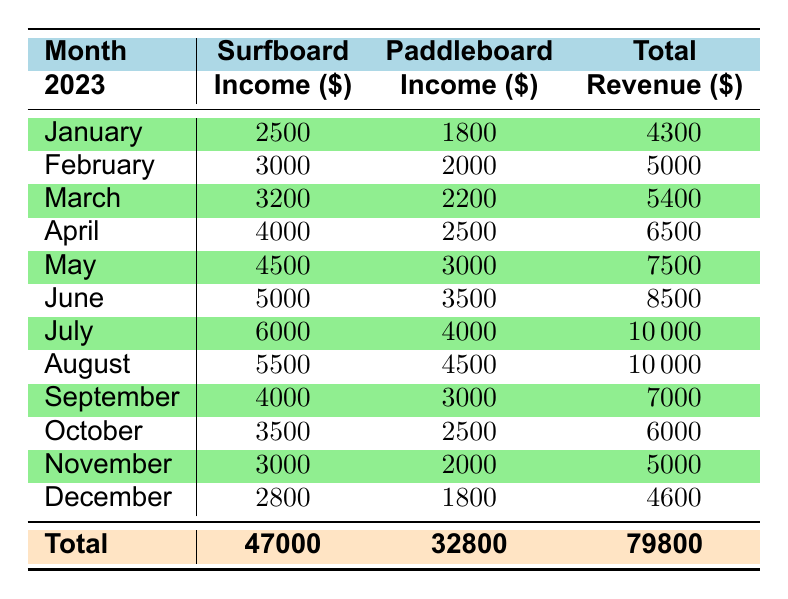What was the surfboard rental income in June 2023? The table shows that in June 2023, the surfboard rental income is listed as 5000.
Answer: 5000 How much income did paddleboard rentals generate in March 2023? According to the table, paddleboard rental income for March 2023 is 2200.
Answer: 2200 What is the total revenue for April 2023? The table lists the total revenue for April 2023 as 6500.
Answer: 6500 In which month did paddleboard rentals earn more than 4000? By checking the table, paddleboard rentals earned more than 4000 in July (4000) and August (4500).
Answer: July and August What was the overall total revenue from surfboard rentals over the year? The total revenue from surfboard rentals, as shown at the bottom of the table, is 47000.
Answer: 47000 What is the difference between the total revenue for January and December? The total revenue for January is 4300 and for December is 4600. The difference is 4600 - 4300 = 300.
Answer: 300 Was there a month where paddleboard rental income was equal to surfboard rental income? Reviewing the table reveals that there was no month with equal paddleboard and surfboard rental income.
Answer: No Which month had the highest total revenue, and how much was it? The highest total revenue is 10000, which occurred in both July and August.
Answer: July and August, 10000 What is the average income from paddleboard rentals over the year? The total paddleboard rental income is 32800, and there are 12 months, so the average is 32800 / 12 = 2733.33.
Answer: 2733.33 Did the income from paddleboard rentals increase every month from January to July 2023? By examining the table, paddleboard rental income increased from January (1800) to July (4000) without any decrease, confirming a consistent increase.
Answer: Yes 